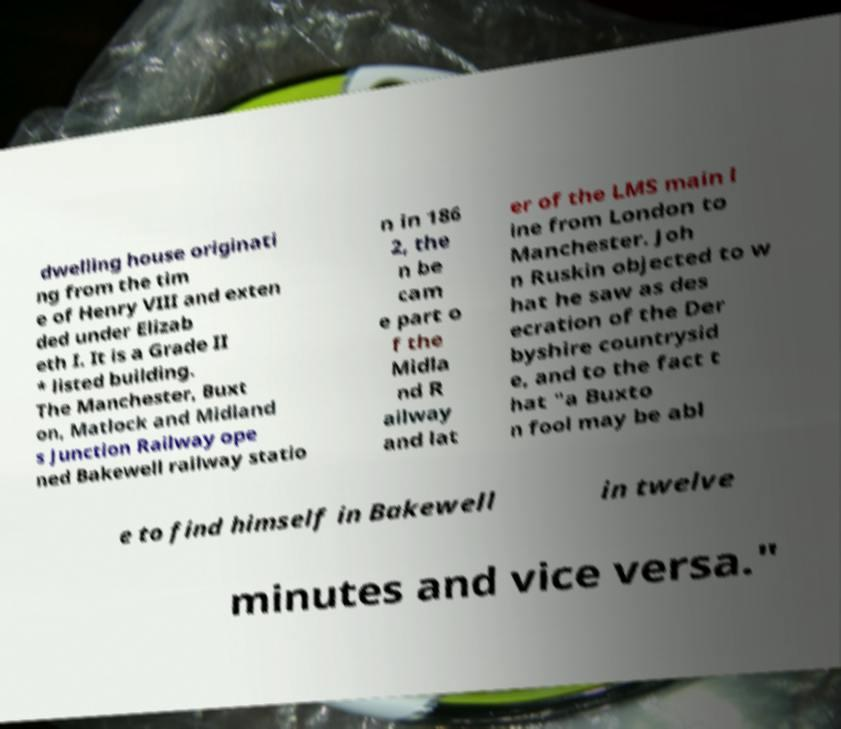What messages or text are displayed in this image? I need them in a readable, typed format. dwelling house originati ng from the tim e of Henry VIII and exten ded under Elizab eth I. It is a Grade II * listed building. The Manchester, Buxt on, Matlock and Midland s Junction Railway ope ned Bakewell railway statio n in 186 2, the n be cam e part o f the Midla nd R ailway and lat er of the LMS main l ine from London to Manchester. Joh n Ruskin objected to w hat he saw as des ecration of the Der byshire countrysid e, and to the fact t hat "a Buxto n fool may be abl e to find himself in Bakewell in twelve minutes and vice versa." 